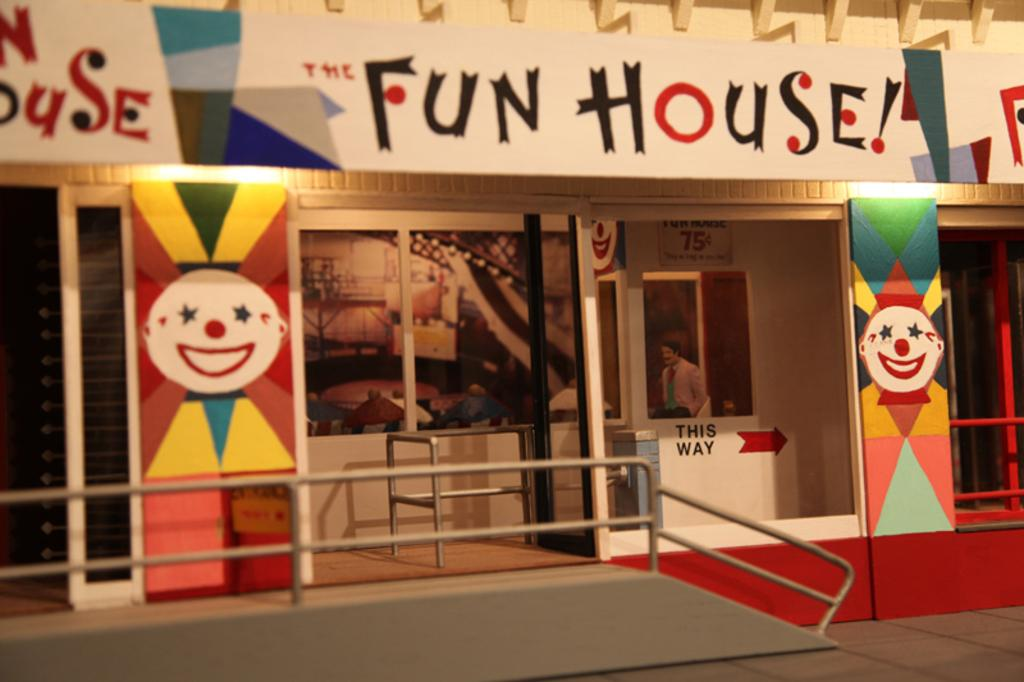<image>
Create a compact narrative representing the image presented. A entrance of The fun house  with the red colored direction sign with lettering This way 